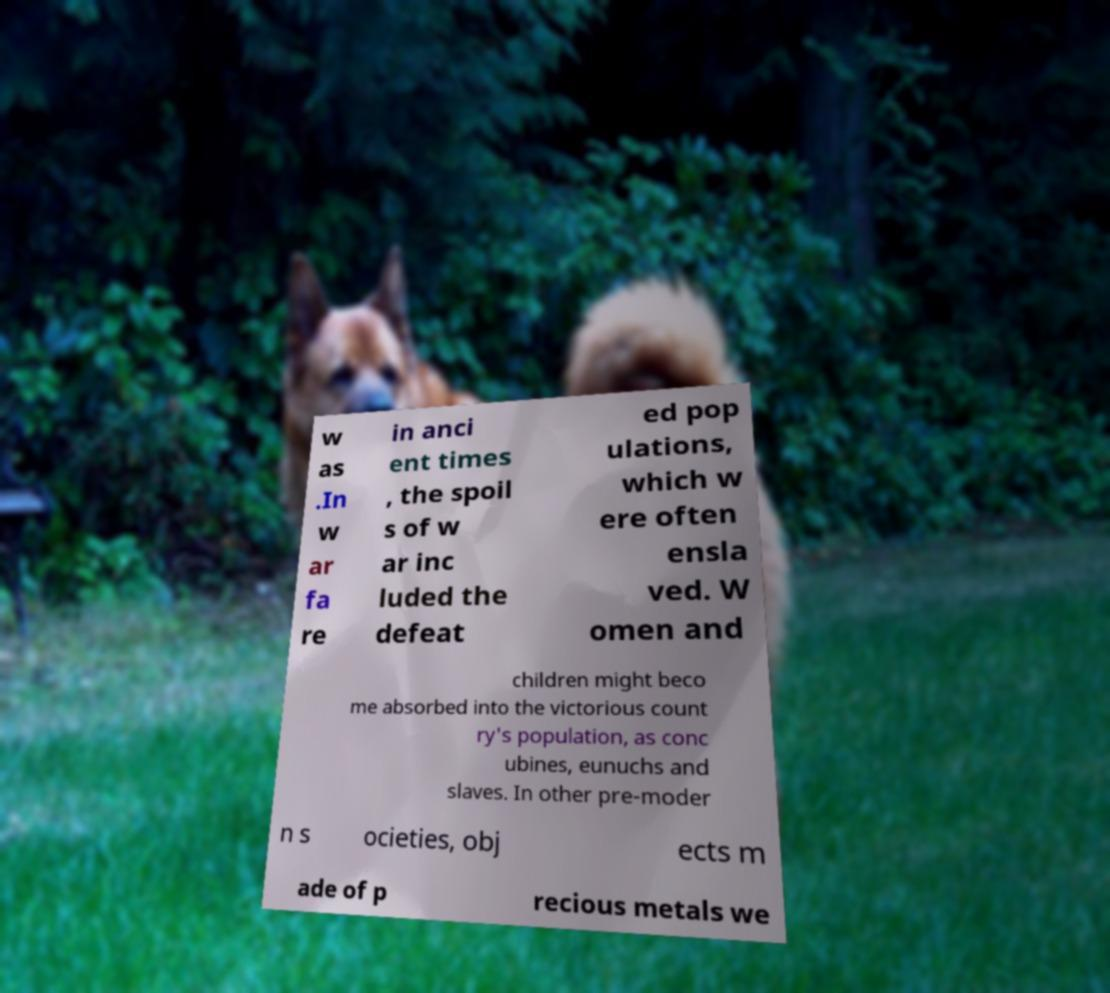Please identify and transcribe the text found in this image. w as .In w ar fa re in anci ent times , the spoil s of w ar inc luded the defeat ed pop ulations, which w ere often ensla ved. W omen and children might beco me absorbed into the victorious count ry's population, as conc ubines, eunuchs and slaves. In other pre-moder n s ocieties, obj ects m ade of p recious metals we 